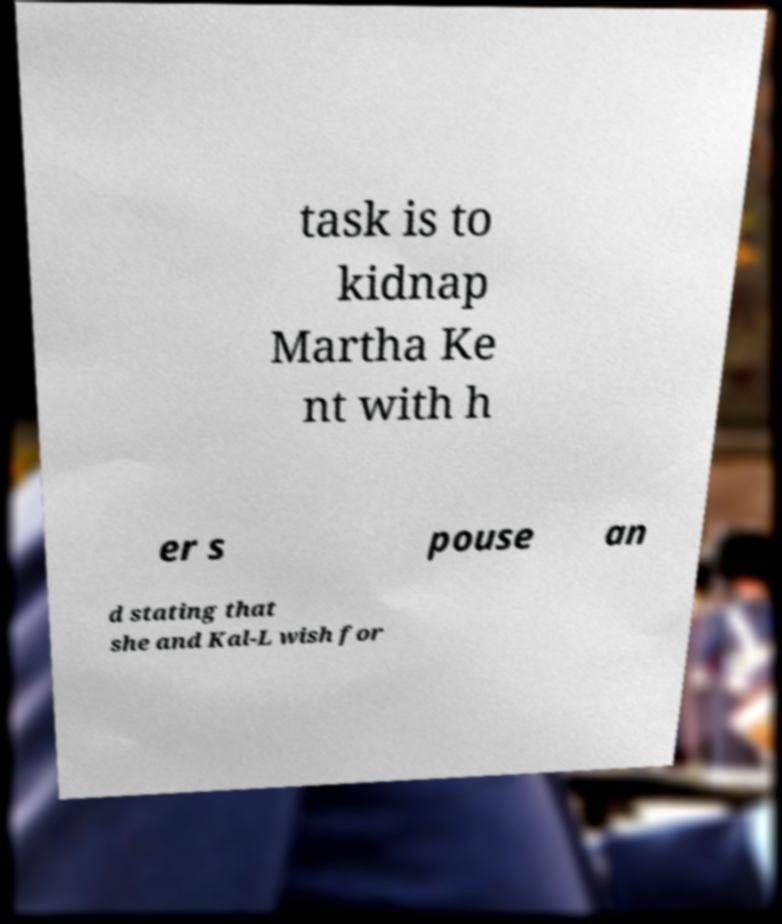Can you read and provide the text displayed in the image?This photo seems to have some interesting text. Can you extract and type it out for me? task is to kidnap Martha Ke nt with h er s pouse an d stating that she and Kal-L wish for 